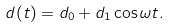Convert formula to latex. <formula><loc_0><loc_0><loc_500><loc_500>d ( t ) = d _ { 0 } + d _ { 1 } \cos \omega t .</formula> 